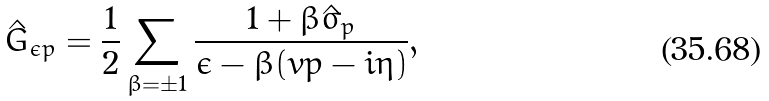<formula> <loc_0><loc_0><loc_500><loc_500>\hat { G } _ { \epsilon { p } } = \frac { 1 } { 2 } \sum _ { \beta = \pm 1 } \frac { 1 + \beta \hat { \sigma } _ { p } } { \epsilon - \beta ( v p - i \eta ) } ,</formula> 